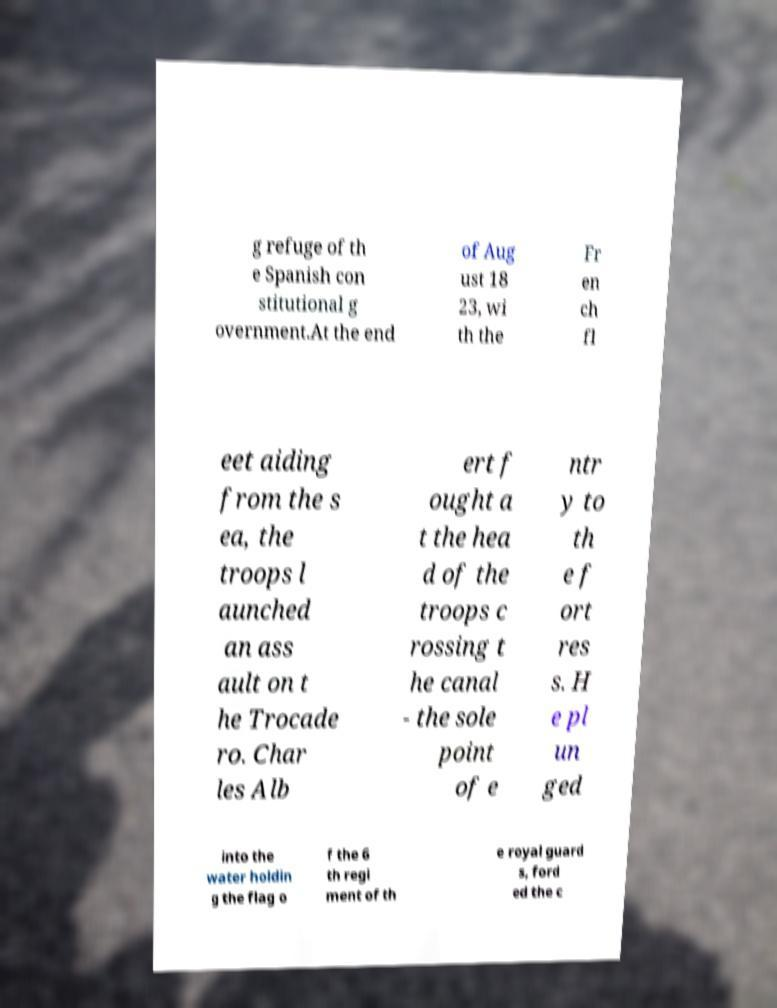Please read and relay the text visible in this image. What does it say? g refuge of th e Spanish con stitutional g overnment.At the end of Aug ust 18 23, wi th the Fr en ch fl eet aiding from the s ea, the troops l aunched an ass ault on t he Trocade ro. Char les Alb ert f ought a t the hea d of the troops c rossing t he canal - the sole point of e ntr y to th e f ort res s. H e pl un ged into the water holdin g the flag o f the 6 th regi ment of th e royal guard s, ford ed the c 